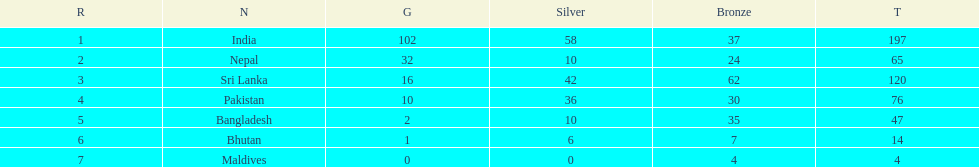Name the first country on the table? India. 